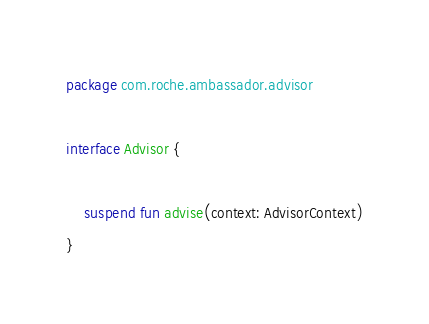Convert code to text. <code><loc_0><loc_0><loc_500><loc_500><_Kotlin_>package com.roche.ambassador.advisor

interface Advisor {

    suspend fun advise(context: AdvisorContext)
}
</code> 